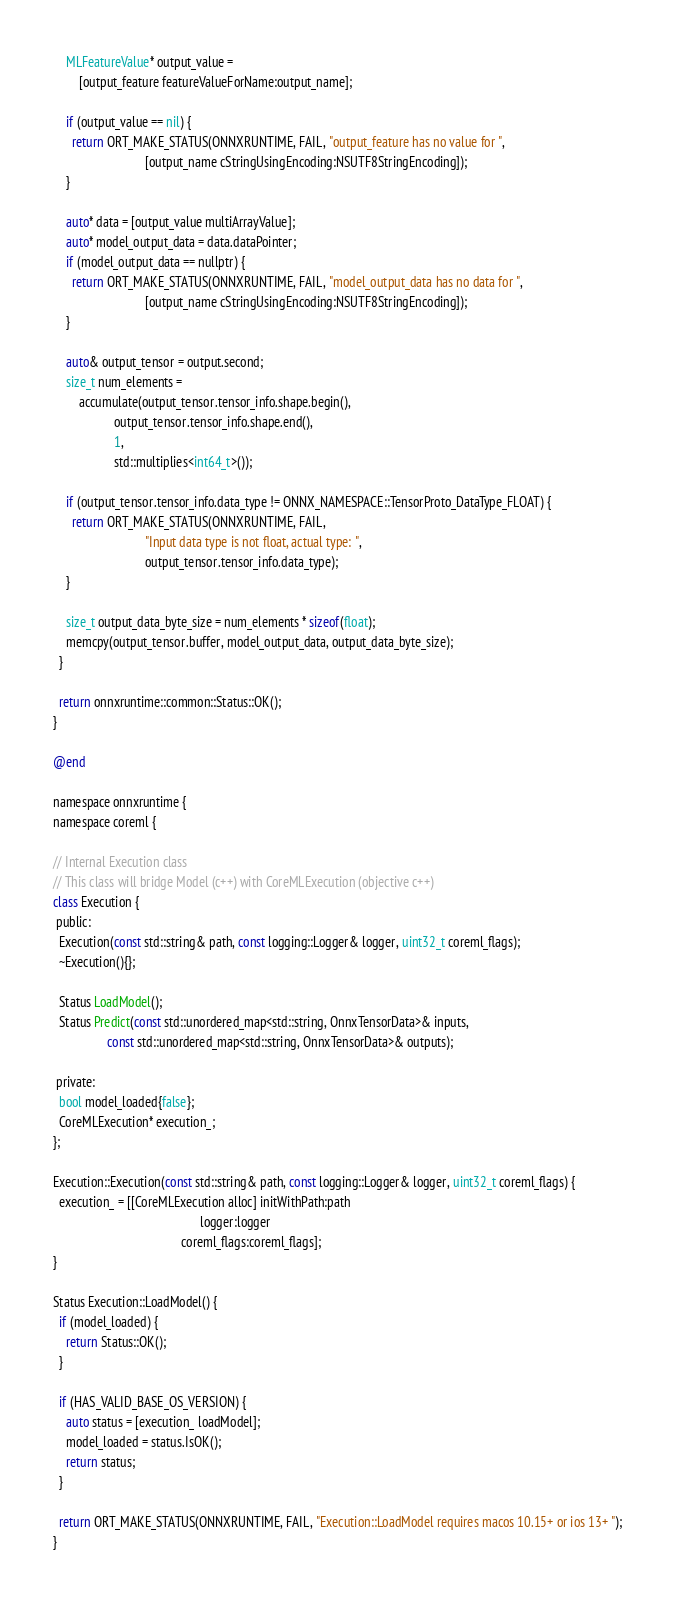<code> <loc_0><loc_0><loc_500><loc_500><_ObjectiveC_>    MLFeatureValue* output_value =
        [output_feature featureValueForName:output_name];

    if (output_value == nil) {
      return ORT_MAKE_STATUS(ONNXRUNTIME, FAIL, "output_feature has no value for ",
                             [output_name cStringUsingEncoding:NSUTF8StringEncoding]);
    }

    auto* data = [output_value multiArrayValue];
    auto* model_output_data = data.dataPointer;
    if (model_output_data == nullptr) {
      return ORT_MAKE_STATUS(ONNXRUNTIME, FAIL, "model_output_data has no data for ",
                             [output_name cStringUsingEncoding:NSUTF8StringEncoding]);
    }

    auto& output_tensor = output.second;
    size_t num_elements =
        accumulate(output_tensor.tensor_info.shape.begin(),
                   output_tensor.tensor_info.shape.end(),
                   1,
                   std::multiplies<int64_t>());

    if (output_tensor.tensor_info.data_type != ONNX_NAMESPACE::TensorProto_DataType_FLOAT) {
      return ORT_MAKE_STATUS(ONNXRUNTIME, FAIL,
                             "Input data type is not float, actual type: ",
                             output_tensor.tensor_info.data_type);
    }

    size_t output_data_byte_size = num_elements * sizeof(float);
    memcpy(output_tensor.buffer, model_output_data, output_data_byte_size);
  }

  return onnxruntime::common::Status::OK();
}

@end

namespace onnxruntime {
namespace coreml {

// Internal Execution class
// This class will bridge Model (c++) with CoreMLExecution (objective c++)
class Execution {
 public:
  Execution(const std::string& path, const logging::Logger& logger, uint32_t coreml_flags);
  ~Execution(){};

  Status LoadModel();
  Status Predict(const std::unordered_map<std::string, OnnxTensorData>& inputs,
                 const std::unordered_map<std::string, OnnxTensorData>& outputs);

 private:
  bool model_loaded{false};
  CoreMLExecution* execution_;
};

Execution::Execution(const std::string& path, const logging::Logger& logger, uint32_t coreml_flags) {
  execution_ = [[CoreMLExecution alloc] initWithPath:path
                                              logger:logger
                                        coreml_flags:coreml_flags];
}

Status Execution::LoadModel() {
  if (model_loaded) {
    return Status::OK();
  }

  if (HAS_VALID_BASE_OS_VERSION) {
    auto status = [execution_ loadModel];
    model_loaded = status.IsOK();
    return status;
  }

  return ORT_MAKE_STATUS(ONNXRUNTIME, FAIL, "Execution::LoadModel requires macos 10.15+ or ios 13+ ");
}
</code> 